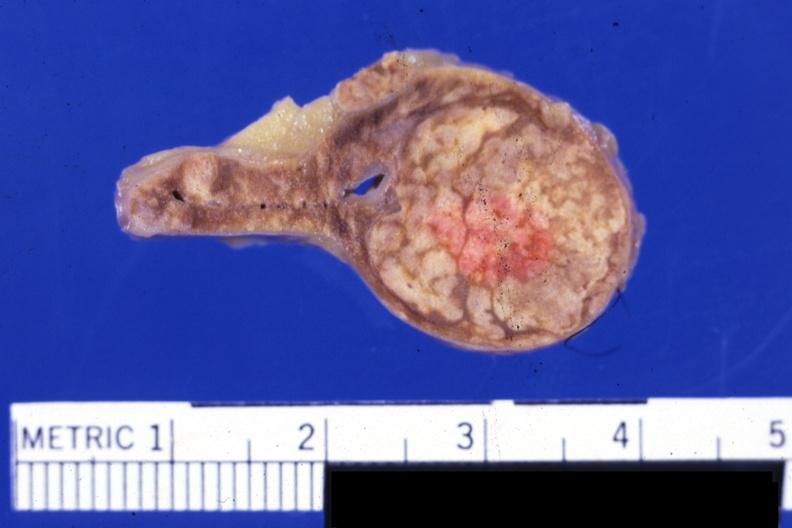s adrenal present?
Answer the question using a single word or phrase. Yes 